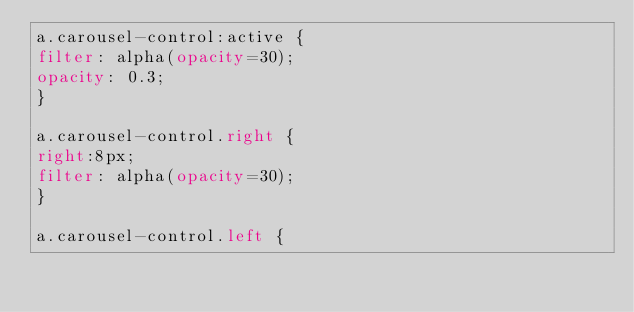<code> <loc_0><loc_0><loc_500><loc_500><_CSS_>a.carousel-control:active {
filter: alpha(opacity=30);
opacity: 0.3;
}

a.carousel-control.right {
right:8px;
filter: alpha(opacity=30);
}

a.carousel-control.left {</code> 